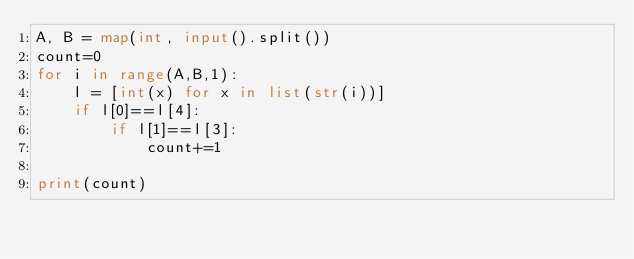<code> <loc_0><loc_0><loc_500><loc_500><_Python_>A, B = map(int, input().split())
count=0
for i in range(A,B,1):
    l = [int(x) for x in list(str(i))]
    if l[0]==l[4]:
        if l[1]==l[3]:
            count+=1

print(count)
</code> 